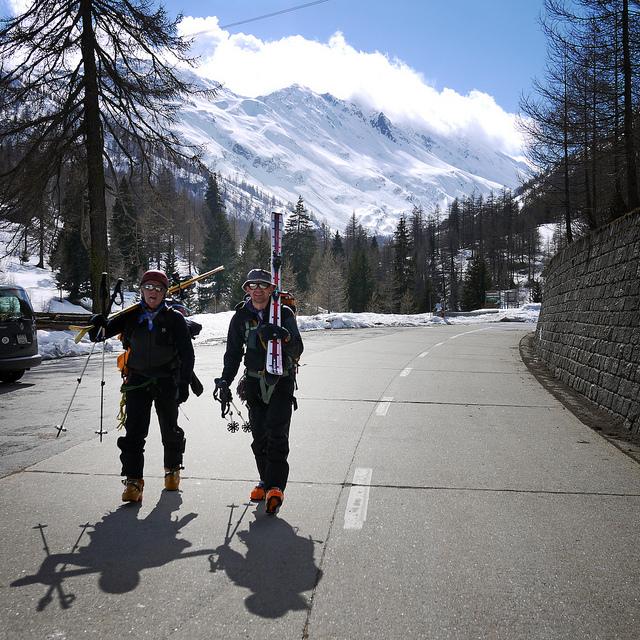Is there snow in the image?
Give a very brief answer. Yes. Why are they walking and not skiing?
Be succinct. No snow. Do the men have sun in their eyes?
Write a very short answer. No. 